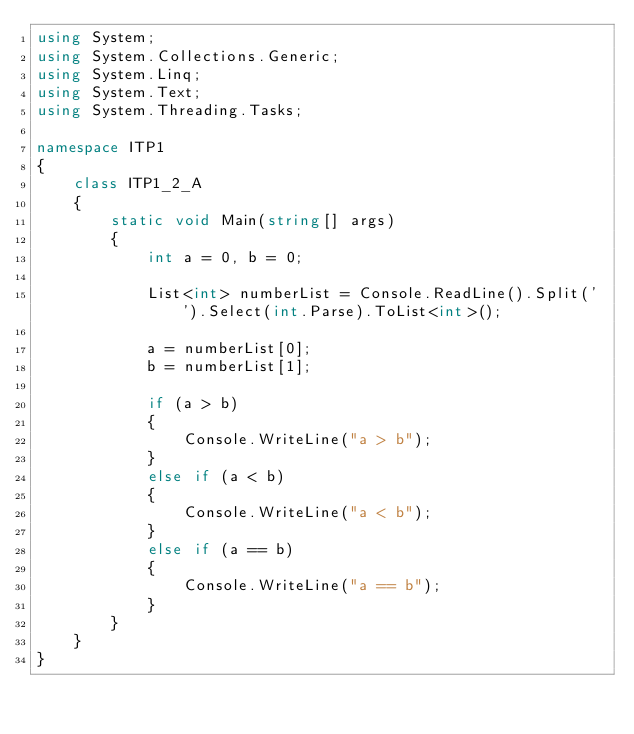Convert code to text. <code><loc_0><loc_0><loc_500><loc_500><_C#_>using System;
using System.Collections.Generic;
using System.Linq;
using System.Text;
using System.Threading.Tasks;

namespace ITP1
{
    class ITP1_2_A
    {
        static void Main(string[] args)
        {
            int a = 0, b = 0;

            List<int> numberList = Console.ReadLine().Split(' ').Select(int.Parse).ToList<int>();

            a = numberList[0];
            b = numberList[1];

            if (a > b)
            {
                Console.WriteLine("a > b");
            }
            else if (a < b)
            {
                Console.WriteLine("a < b");
            }
            else if (a == b)
            {
                Console.WriteLine("a == b");
            }
        }
    }
}

</code> 